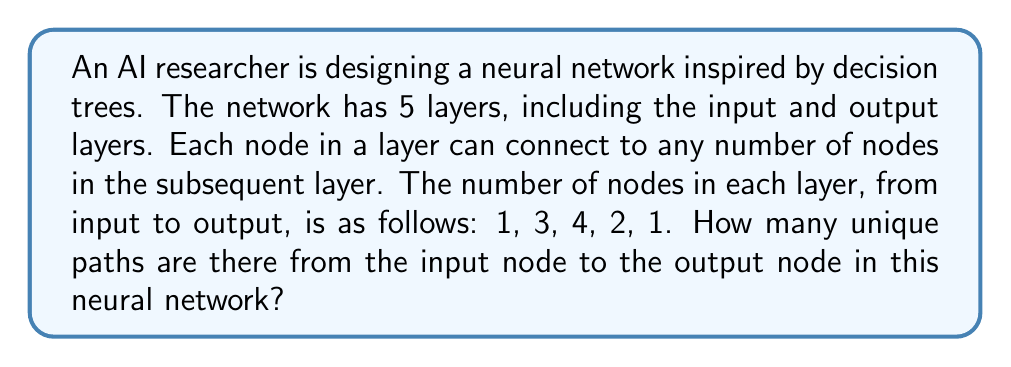What is the answer to this math problem? Let's approach this problem step by step:

1) First, we need to understand that this problem is equivalent to finding the number of unique paths through a decision tree with varying depths.

2) We can solve this using the multiplication principle. The number of unique paths is the product of the number of choices at each step.

3) Let's break it down by layer:
   - From the input layer (1 node) to the second layer (3 nodes): 3 choices
   - From the second layer (3 nodes) to the third layer (4 nodes): 4 choices for each of the 3 nodes
   - From the third layer (4 nodes) to the fourth layer (2 nodes): 2 choices for each of the 4 nodes
   - From the fourth layer (2 nodes) to the output layer (1 node): 1 choice for each of the 2 nodes

4) Applying the multiplication principle:

   $$\text{Total paths} = 3 \times 4 \times 2 \times 1 = 24$$

5) However, this is for a single path from the second to the third layer. We need to consider all possible paths from the second to the third layer. There are 3 nodes in the second layer, so we need to multiply our result by 3:

   $$\text{Total paths} = 3 \times (3 \times 4 \times 2 \times 1) = 3 \times 24 = 72$$

Therefore, there are 72 unique paths from the input node to the output node in this neural network.
Answer: 72 